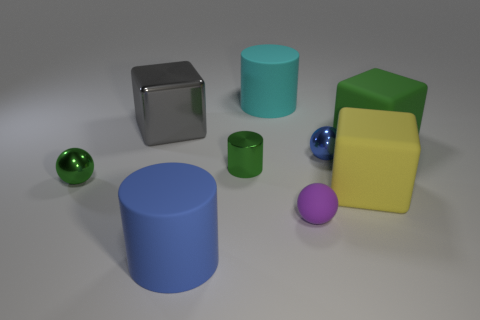Is the shape of the tiny blue metallic object the same as the big gray shiny object?
Keep it short and to the point. No. Is there any other thing that has the same shape as the cyan rubber object?
Your answer should be compact. Yes. There is a cube that is to the left of the yellow rubber object; is it the same color as the tiny sphere left of the blue matte thing?
Your response must be concise. No. Is the number of blue matte things in front of the blue cylinder less than the number of matte blocks that are in front of the yellow matte object?
Offer a terse response. No. There is a blue object that is in front of the tiny purple rubber ball; what shape is it?
Your answer should be compact. Cylinder. There is a large cube that is the same color as the metal cylinder; what is it made of?
Offer a very short reply. Rubber. What number of other objects are the same material as the big green block?
Ensure brevity in your answer.  4. Does the big green matte object have the same shape as the blue thing left of the cyan rubber cylinder?
Provide a succinct answer. No. The other small thing that is made of the same material as the yellow object is what shape?
Give a very brief answer. Sphere. Are there more spheres in front of the big blue matte object than small cylinders that are to the left of the small rubber object?
Provide a succinct answer. No. 